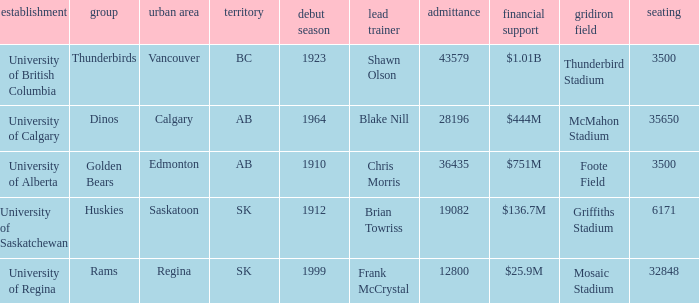What year did University of Saskatchewan have their first season? 1912.0. 